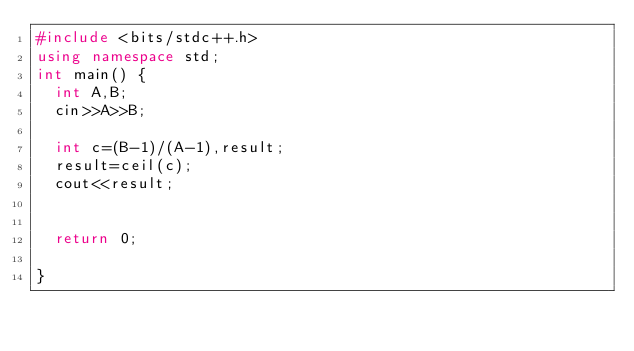Convert code to text. <code><loc_0><loc_0><loc_500><loc_500><_C++_>#include <bits/stdc++.h>
using namespace std;
int main() {
  int A,B;
  cin>>A>>B;
  
	int c=(B-1)/(A-1),result;
	result=ceil(c);
 	cout<<result;
  
  
  return 0;
  
}</code> 